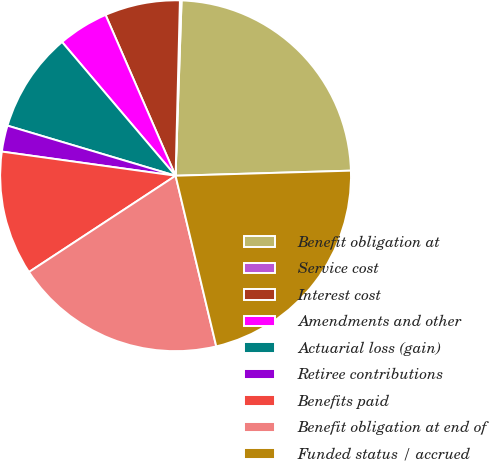<chart> <loc_0><loc_0><loc_500><loc_500><pie_chart><fcel>Benefit obligation at<fcel>Service cost<fcel>Interest cost<fcel>Amendments and other<fcel>Actuarial loss (gain)<fcel>Retiree contributions<fcel>Benefits paid<fcel>Benefit obligation at end of<fcel>Funded status / accrued<nl><fcel>24.0%<fcel>0.15%<fcel>6.93%<fcel>4.67%<fcel>9.19%<fcel>2.41%<fcel>11.45%<fcel>19.48%<fcel>21.74%<nl></chart> 